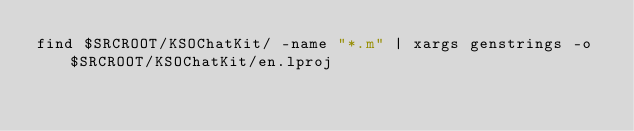<code> <loc_0><loc_0><loc_500><loc_500><_Bash_>find $SRCROOT/KSOChatKit/ -name "*.m" | xargs genstrings -o $SRCROOT/KSOChatKit/en.lproj</code> 